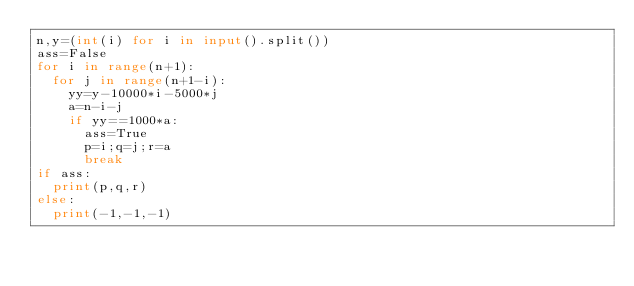Convert code to text. <code><loc_0><loc_0><loc_500><loc_500><_Python_>n,y=(int(i) for i in input().split())
ass=False
for i in range(n+1):
  for j in range(n+1-i):
    yy=y-10000*i-5000*j
    a=n-i-j
    if yy==1000*a:
      ass=True
      p=i;q=j;r=a
      break
if ass:
  print(p,q,r)
else:
  print(-1,-1,-1)</code> 